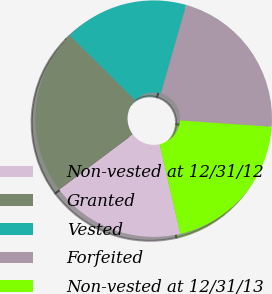Convert chart. <chart><loc_0><loc_0><loc_500><loc_500><pie_chart><fcel>Non-vested at 12/31/12<fcel>Granted<fcel>Vested<fcel>Forfeited<fcel>Non-vested at 12/31/13<nl><fcel>18.37%<fcel>22.67%<fcel>17.0%<fcel>21.67%<fcel>20.29%<nl></chart> 